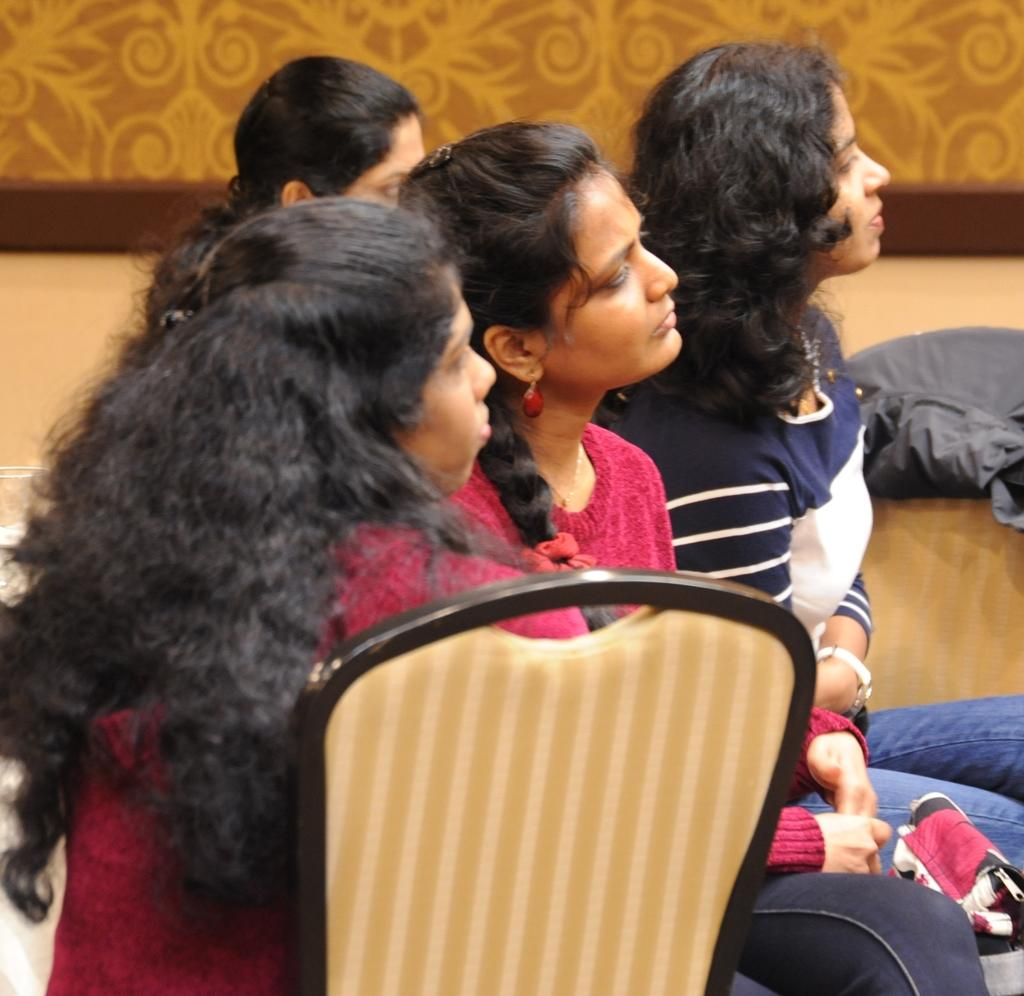Who is present in the image? There are women in the image. What are the women doing in the image? The women are sitting on chairs. What can be seen in the background of the image? There is a wall in the background of the image. What direction are the women's nerves heading in the image? There is no mention of nerves in the image, and the direction of the women's nerves cannot be determined. 